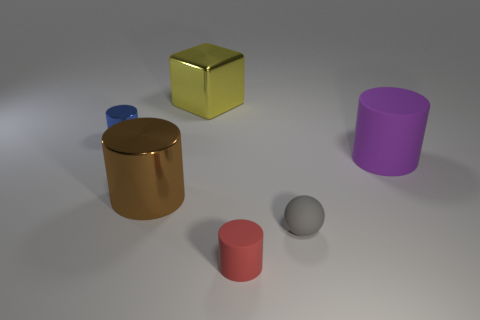Add 1 tiny red matte cylinders. How many objects exist? 7 Subtract all spheres. How many objects are left? 5 Add 6 red rubber cylinders. How many red rubber cylinders are left? 7 Add 5 big gray matte objects. How many big gray matte objects exist? 5 Subtract 0 cyan cubes. How many objects are left? 6 Subtract all large green objects. Subtract all yellow cubes. How many objects are left? 5 